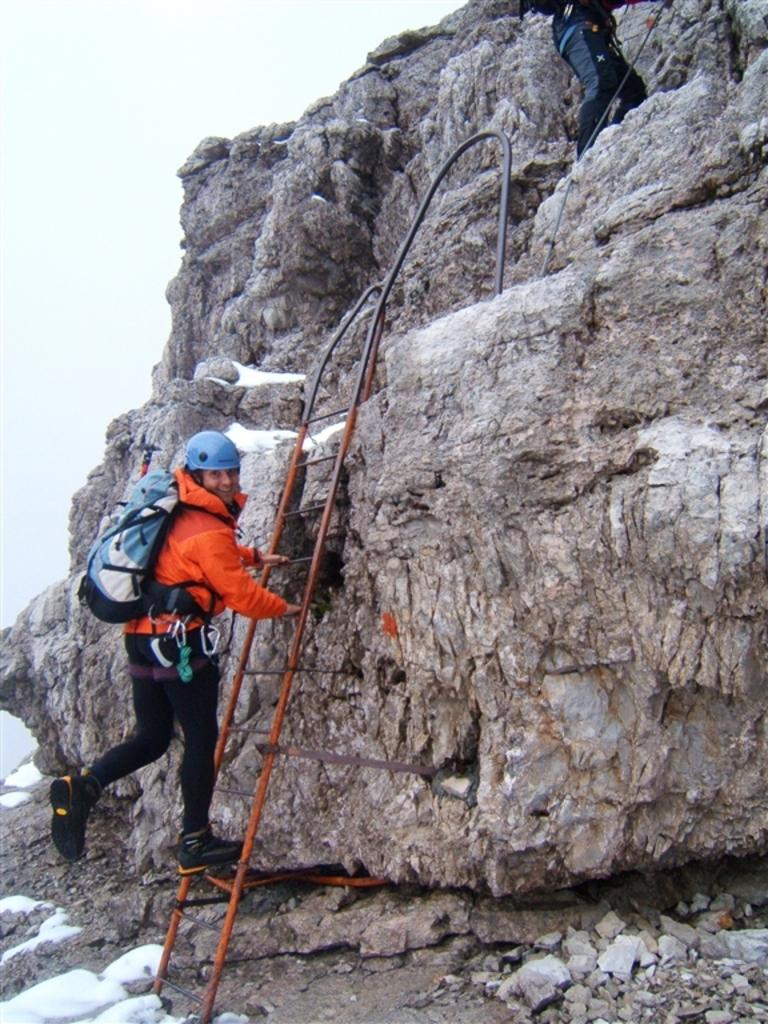What geographical feature is present in the image? There is a hill in the image. What objects are on the hill? There is a rope and a ladder on the hill. What are the two persons in the image doing? The two persons are climbing the hill. What can be seen in the top left corner of the image? The sky is visible in the top left corner of the image. What type of cushion can be seen on the hill in the image? There is no cushion present on the hill in the image. How many pages are visible in the image? There are no pages visible in the image. 